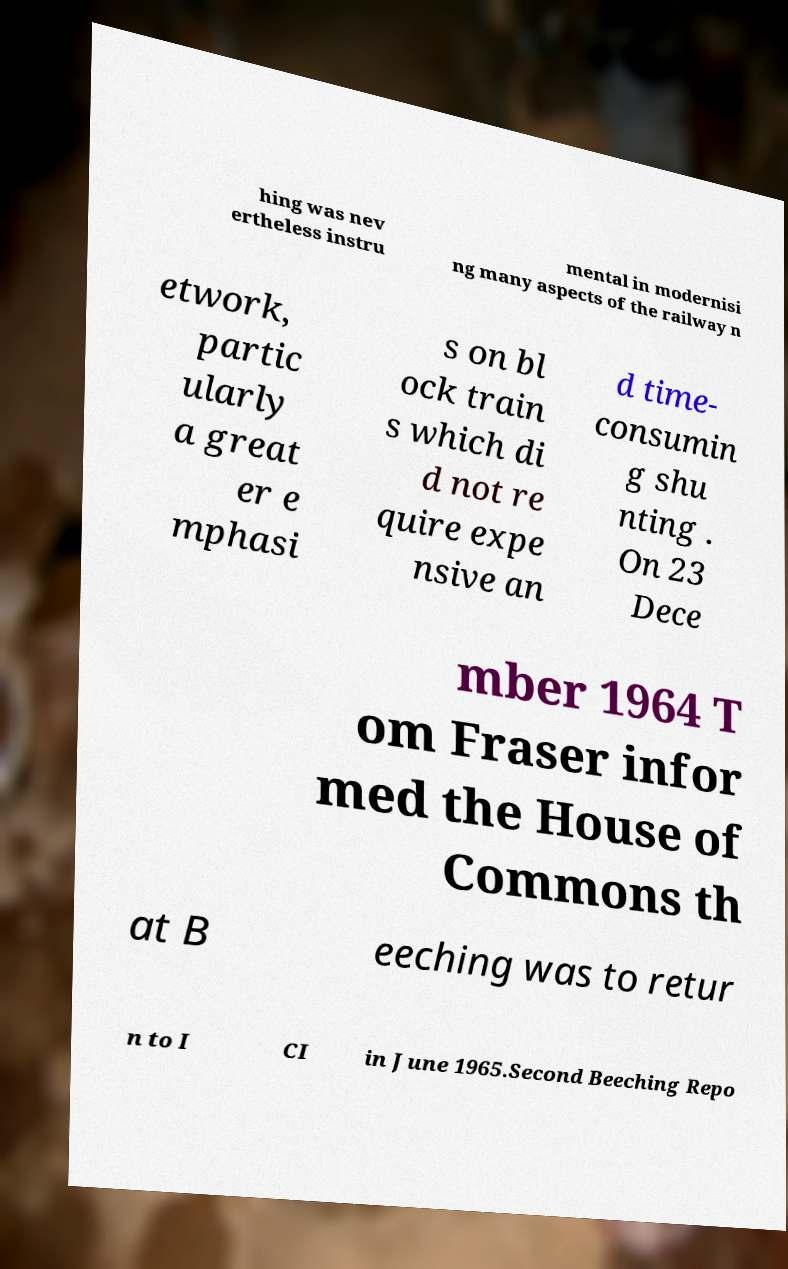I need the written content from this picture converted into text. Can you do that? hing was nev ertheless instru mental in modernisi ng many aspects of the railway n etwork, partic ularly a great er e mphasi s on bl ock train s which di d not re quire expe nsive an d time- consumin g shu nting . On 23 Dece mber 1964 T om Fraser infor med the House of Commons th at B eeching was to retur n to I CI in June 1965.Second Beeching Repo 